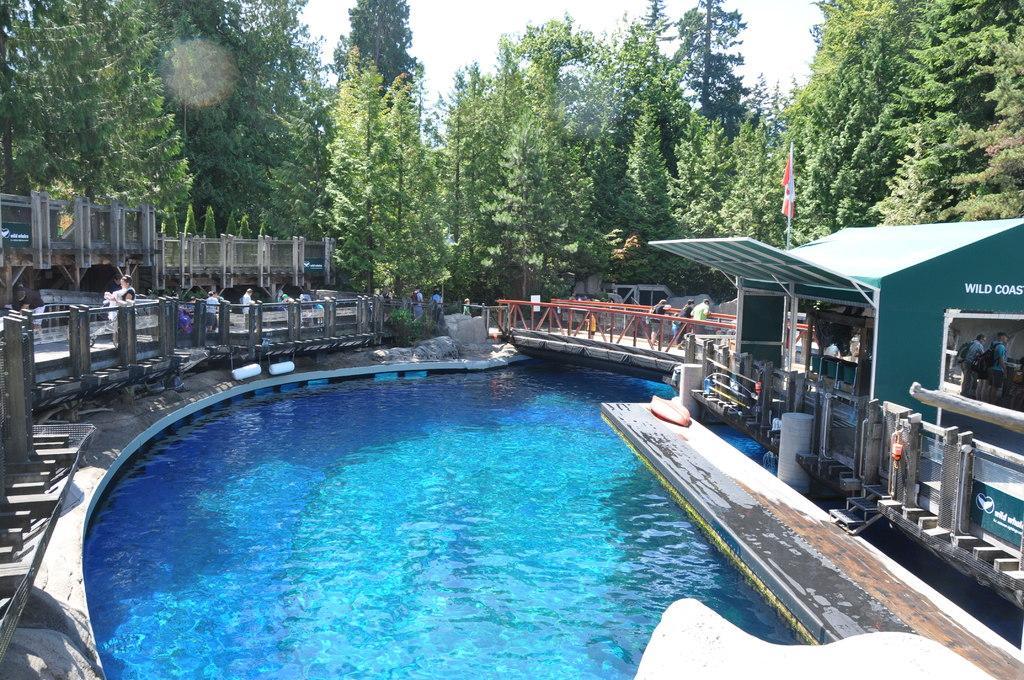How would you summarize this image in a sentence or two? In this image I can see a pool a bridge on the pool and some people standing on the bridge. A walkway a person walking on the walkway. A shed on the right hand side and two people under the shed. I can see the trees at the top of the image beneath the sky. I can see a flag on the shed. 